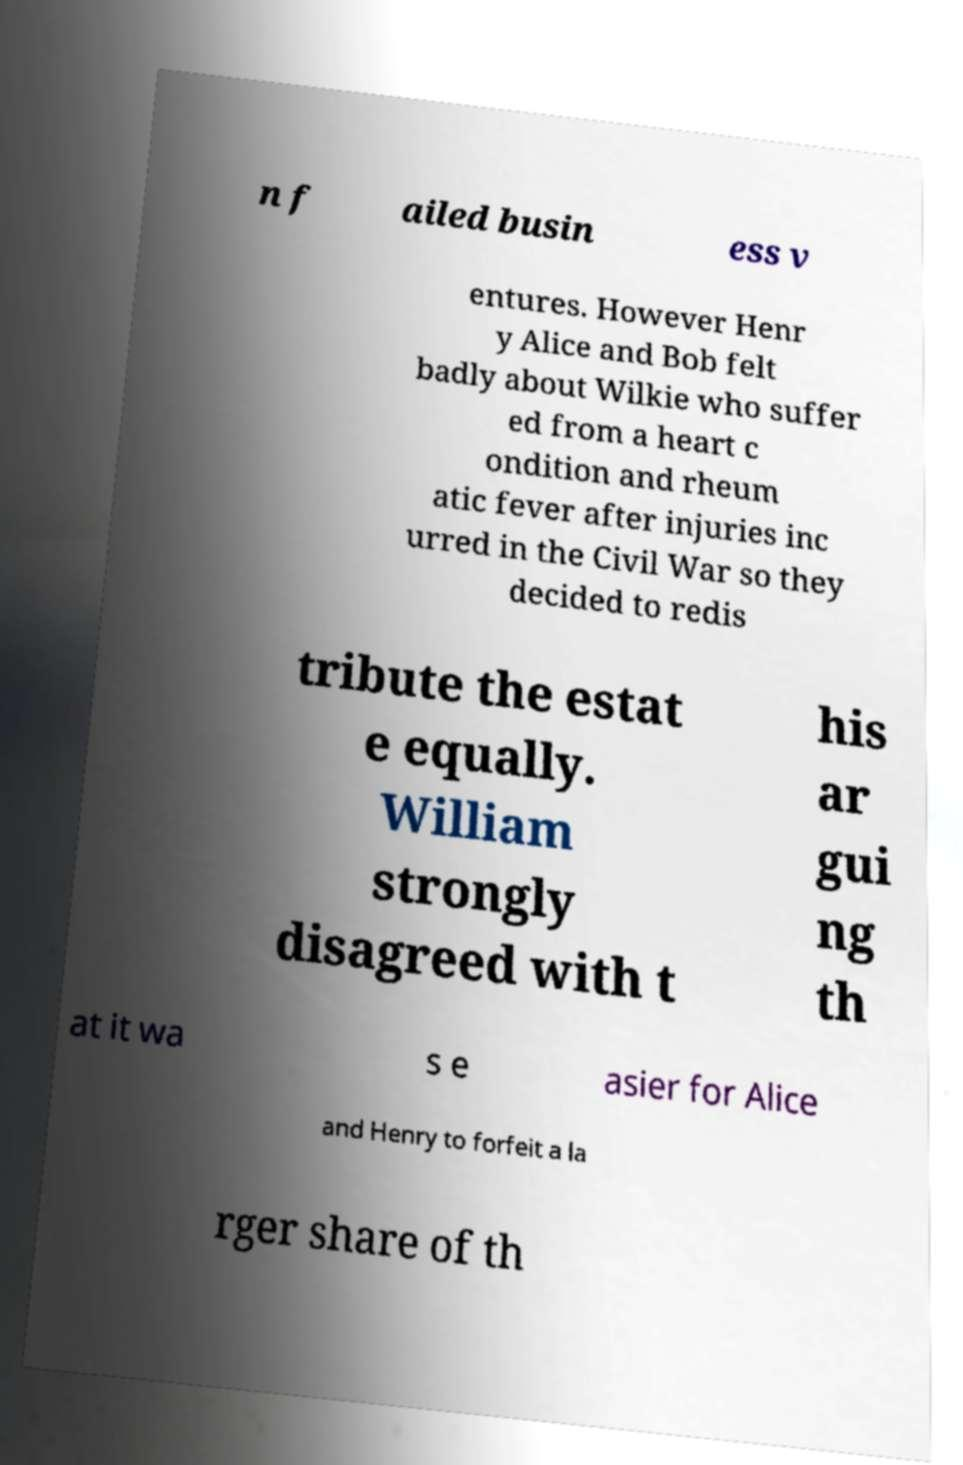Can you read and provide the text displayed in the image?This photo seems to have some interesting text. Can you extract and type it out for me? n f ailed busin ess v entures. However Henr y Alice and Bob felt badly about Wilkie who suffer ed from a heart c ondition and rheum atic fever after injuries inc urred in the Civil War so they decided to redis tribute the estat e equally. William strongly disagreed with t his ar gui ng th at it wa s e asier for Alice and Henry to forfeit a la rger share of th 